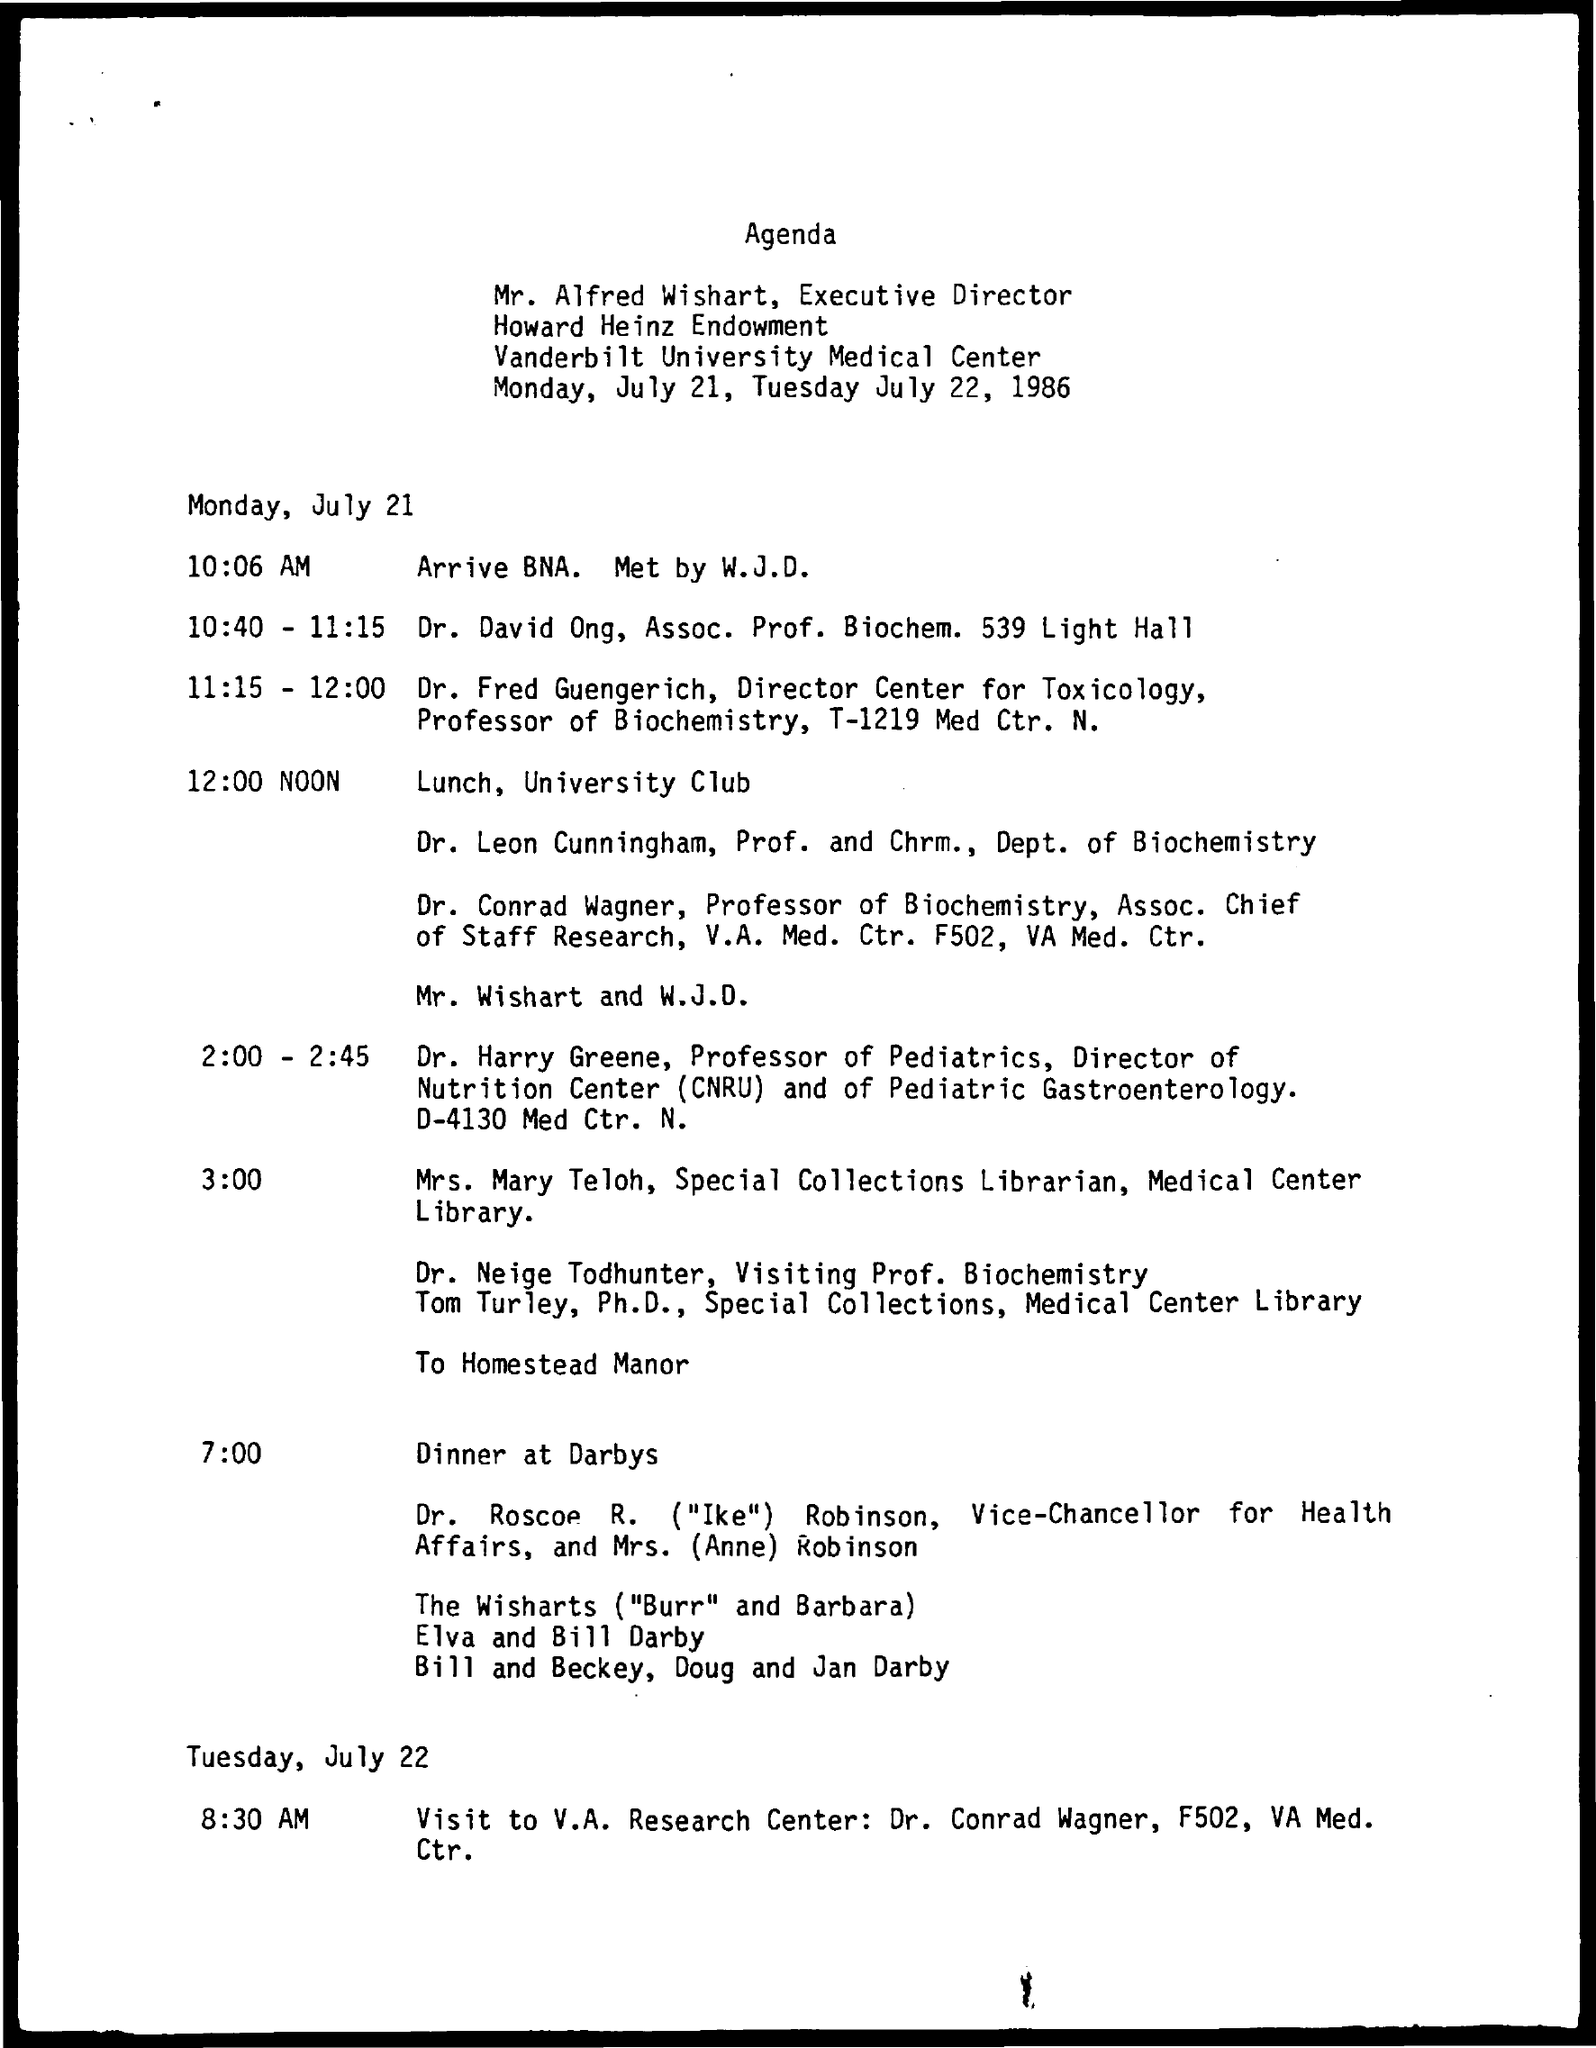Highlight a few significant elements in this photo. The lunch on Monday, July 21st will be organized at 12:00 Noon. Mr. Alfred Wishart's designation is Executive Director. The Special Collections Librarian at the Medical Center Library is named Mrs. Mary Teloh. 